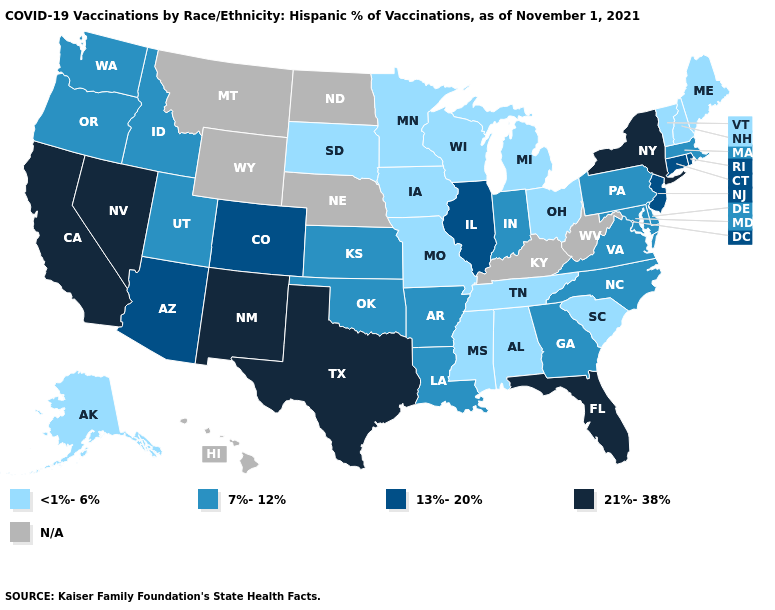What is the lowest value in the Northeast?
Answer briefly. <1%-6%. Name the states that have a value in the range 21%-38%?
Be succinct. California, Florida, Nevada, New Mexico, New York, Texas. Is the legend a continuous bar?
Quick response, please. No. Among the states that border New York , does Connecticut have the highest value?
Concise answer only. Yes. Among the states that border Arkansas , does Mississippi have the lowest value?
Concise answer only. Yes. Which states have the highest value in the USA?
Give a very brief answer. California, Florida, Nevada, New Mexico, New York, Texas. Name the states that have a value in the range N/A?
Concise answer only. Hawaii, Kentucky, Montana, Nebraska, North Dakota, West Virginia, Wyoming. Does Texas have the highest value in the South?
Keep it brief. Yes. What is the value of Arizona?
Be succinct. 13%-20%. Among the states that border Kansas , does Colorado have the highest value?
Answer briefly. Yes. Which states have the lowest value in the Northeast?
Be succinct. Maine, New Hampshire, Vermont. What is the value of Nevada?
Write a very short answer. 21%-38%. What is the value of North Dakota?
Write a very short answer. N/A. Does Nevada have the highest value in the USA?
Quick response, please. Yes. Name the states that have a value in the range 13%-20%?
Short answer required. Arizona, Colorado, Connecticut, Illinois, New Jersey, Rhode Island. 